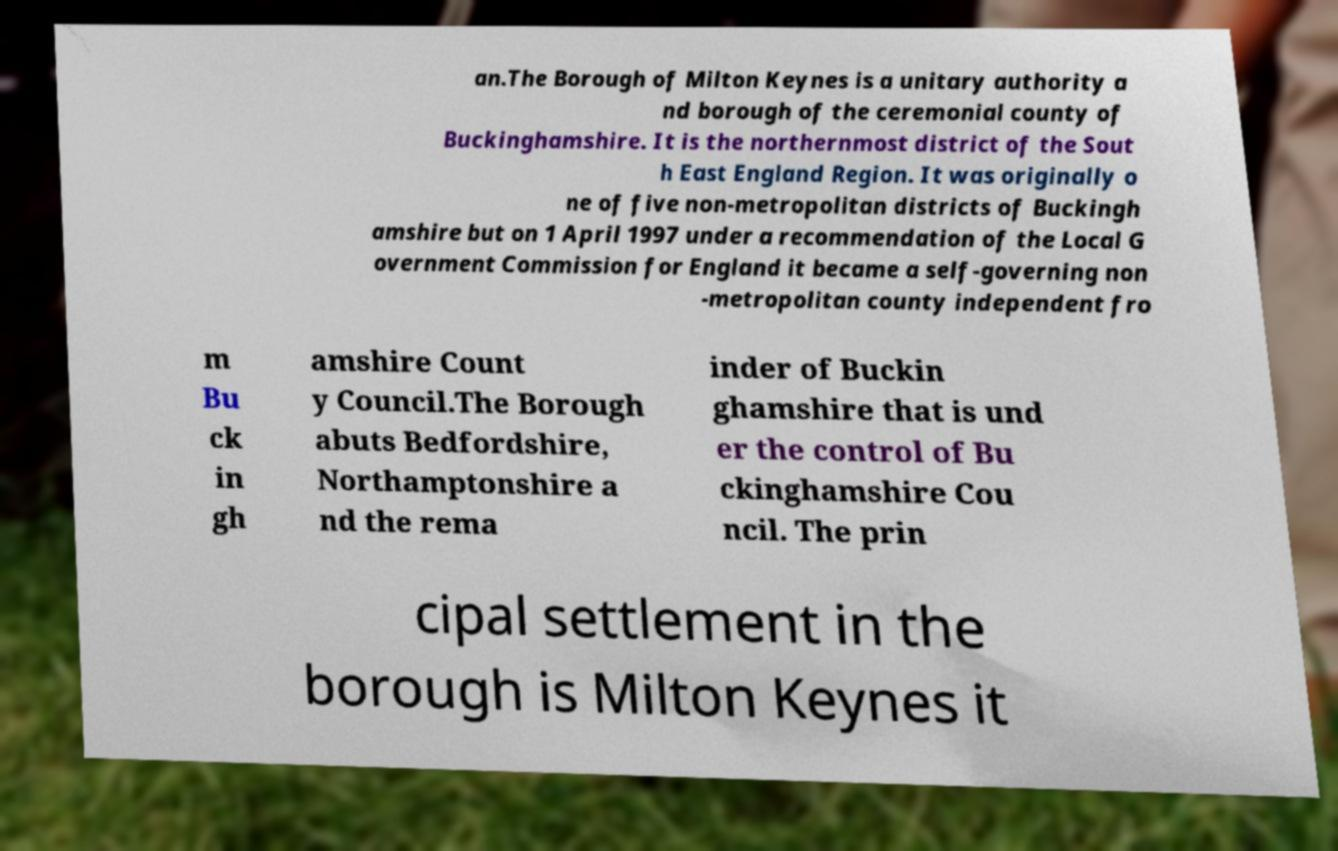Please read and relay the text visible in this image. What does it say? an.The Borough of Milton Keynes is a unitary authority a nd borough of the ceremonial county of Buckinghamshire. It is the northernmost district of the Sout h East England Region. It was originally o ne of five non-metropolitan districts of Buckingh amshire but on 1 April 1997 under a recommendation of the Local G overnment Commission for England it became a self-governing non -metropolitan county independent fro m Bu ck in gh amshire Count y Council.The Borough abuts Bedfordshire, Northamptonshire a nd the rema inder of Buckin ghamshire that is und er the control of Bu ckinghamshire Cou ncil. The prin cipal settlement in the borough is Milton Keynes it 